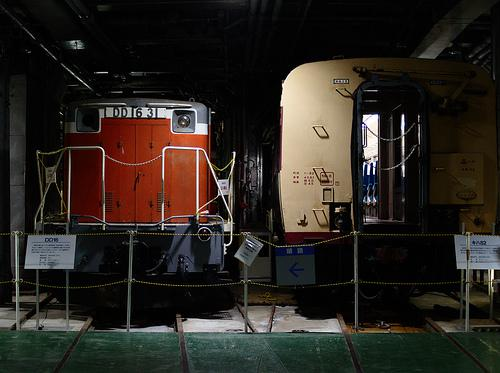Question: what is in the photo?
Choices:
A. A car.
B. A taxi.
C. A bus.
D. Train.
Answer with the letter. Answer: D Question: who is present?
Choices:
A. The pilot.
B. The police officer.
C. No one.
D. The groom.
Answer with the letter. Answer: C Question: why are they motionless?
Choices:
A. There are no waves.
B. The tire is flat.
C. The light is red.
D. Parked.
Answer with the letter. Answer: D Question: where is this scene?
Choices:
A. On the sidewalk.
B. In a parking lot.
C. At the fire station.
D. Near the stage.
Answer with the letter. Answer: D 